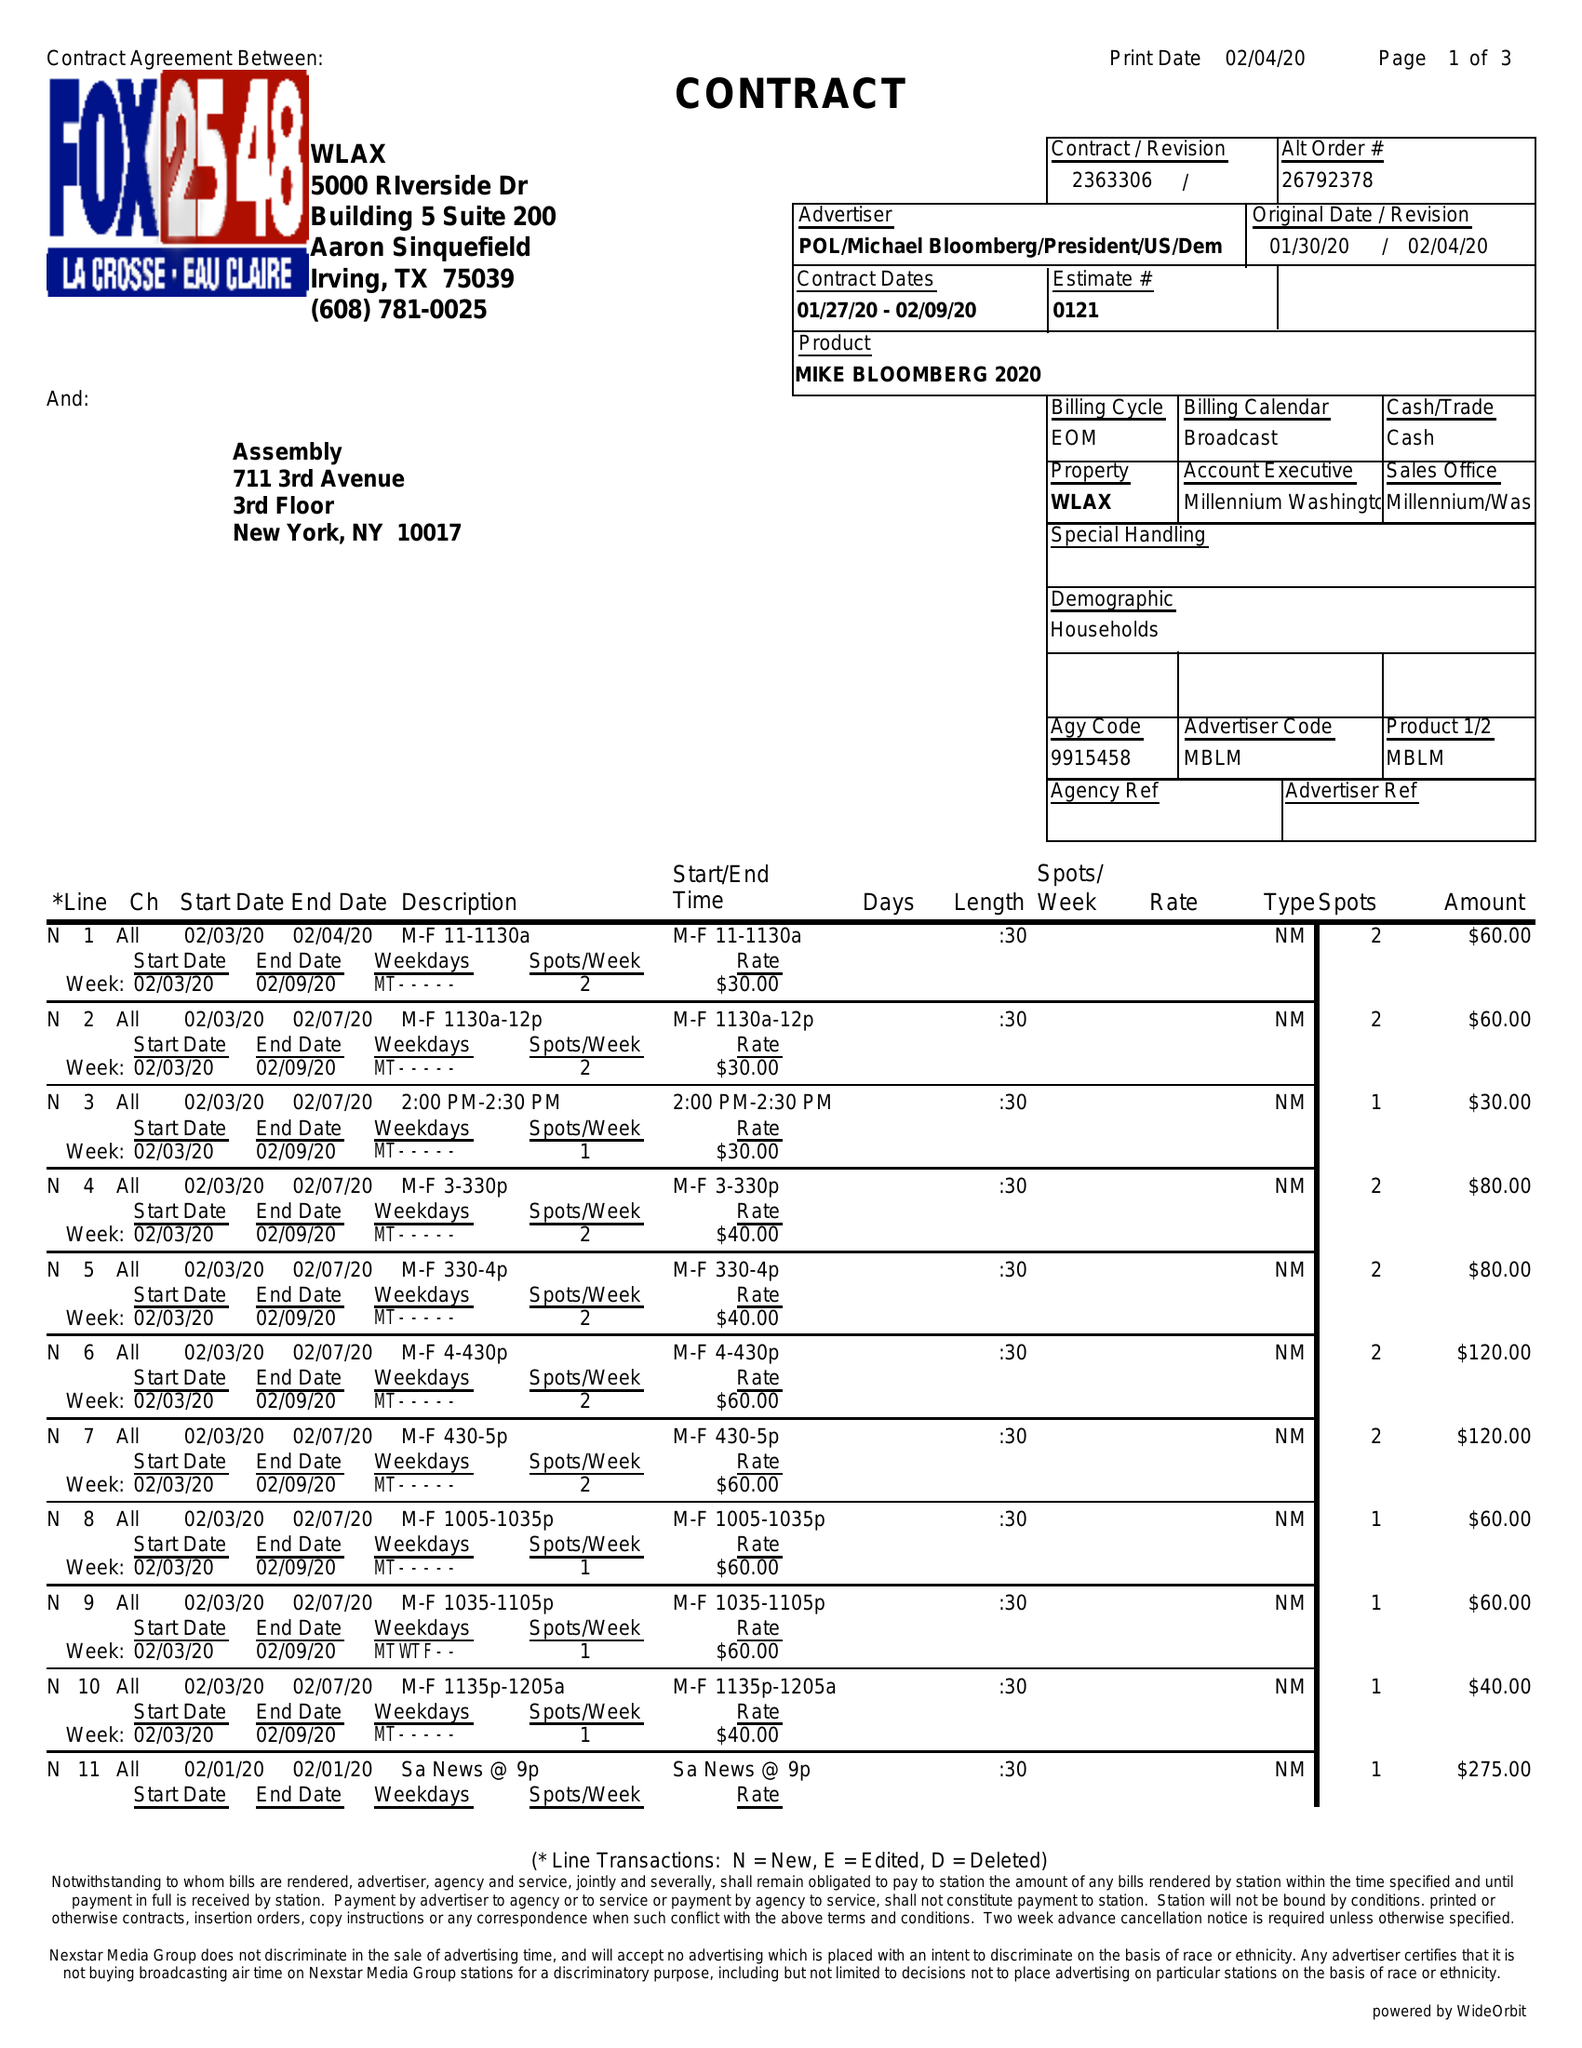What is the value for the gross_amount?
Answer the question using a single word or phrase. 16055.00 